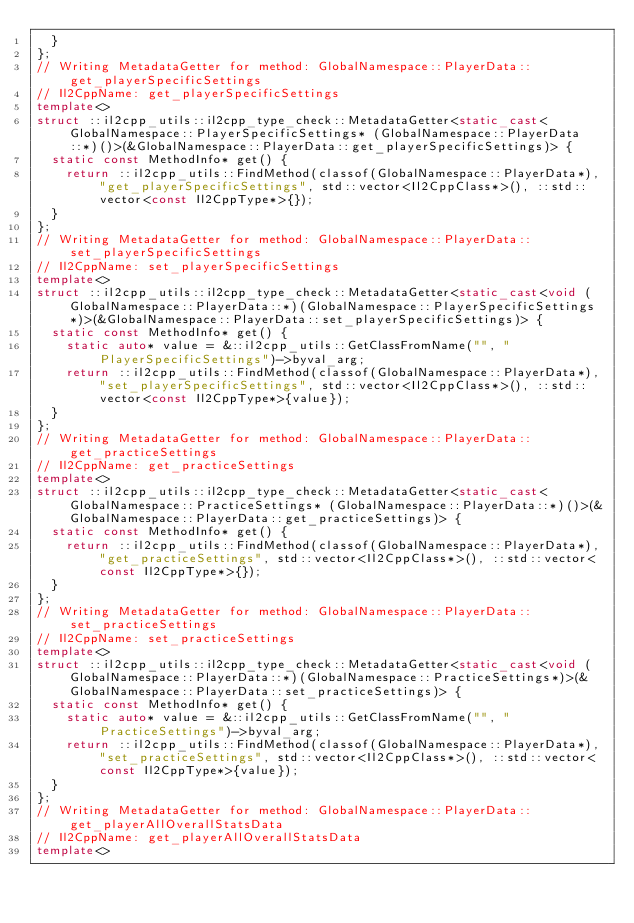Convert code to text. <code><loc_0><loc_0><loc_500><loc_500><_C++_>  }
};
// Writing MetadataGetter for method: GlobalNamespace::PlayerData::get_playerSpecificSettings
// Il2CppName: get_playerSpecificSettings
template<>
struct ::il2cpp_utils::il2cpp_type_check::MetadataGetter<static_cast<GlobalNamespace::PlayerSpecificSettings* (GlobalNamespace::PlayerData::*)()>(&GlobalNamespace::PlayerData::get_playerSpecificSettings)> {
  static const MethodInfo* get() {
    return ::il2cpp_utils::FindMethod(classof(GlobalNamespace::PlayerData*), "get_playerSpecificSettings", std::vector<Il2CppClass*>(), ::std::vector<const Il2CppType*>{});
  }
};
// Writing MetadataGetter for method: GlobalNamespace::PlayerData::set_playerSpecificSettings
// Il2CppName: set_playerSpecificSettings
template<>
struct ::il2cpp_utils::il2cpp_type_check::MetadataGetter<static_cast<void (GlobalNamespace::PlayerData::*)(GlobalNamespace::PlayerSpecificSettings*)>(&GlobalNamespace::PlayerData::set_playerSpecificSettings)> {
  static const MethodInfo* get() {
    static auto* value = &::il2cpp_utils::GetClassFromName("", "PlayerSpecificSettings")->byval_arg;
    return ::il2cpp_utils::FindMethod(classof(GlobalNamespace::PlayerData*), "set_playerSpecificSettings", std::vector<Il2CppClass*>(), ::std::vector<const Il2CppType*>{value});
  }
};
// Writing MetadataGetter for method: GlobalNamespace::PlayerData::get_practiceSettings
// Il2CppName: get_practiceSettings
template<>
struct ::il2cpp_utils::il2cpp_type_check::MetadataGetter<static_cast<GlobalNamespace::PracticeSettings* (GlobalNamespace::PlayerData::*)()>(&GlobalNamespace::PlayerData::get_practiceSettings)> {
  static const MethodInfo* get() {
    return ::il2cpp_utils::FindMethod(classof(GlobalNamespace::PlayerData*), "get_practiceSettings", std::vector<Il2CppClass*>(), ::std::vector<const Il2CppType*>{});
  }
};
// Writing MetadataGetter for method: GlobalNamespace::PlayerData::set_practiceSettings
// Il2CppName: set_practiceSettings
template<>
struct ::il2cpp_utils::il2cpp_type_check::MetadataGetter<static_cast<void (GlobalNamespace::PlayerData::*)(GlobalNamespace::PracticeSettings*)>(&GlobalNamespace::PlayerData::set_practiceSettings)> {
  static const MethodInfo* get() {
    static auto* value = &::il2cpp_utils::GetClassFromName("", "PracticeSettings")->byval_arg;
    return ::il2cpp_utils::FindMethod(classof(GlobalNamespace::PlayerData*), "set_practiceSettings", std::vector<Il2CppClass*>(), ::std::vector<const Il2CppType*>{value});
  }
};
// Writing MetadataGetter for method: GlobalNamespace::PlayerData::get_playerAllOverallStatsData
// Il2CppName: get_playerAllOverallStatsData
template<></code> 